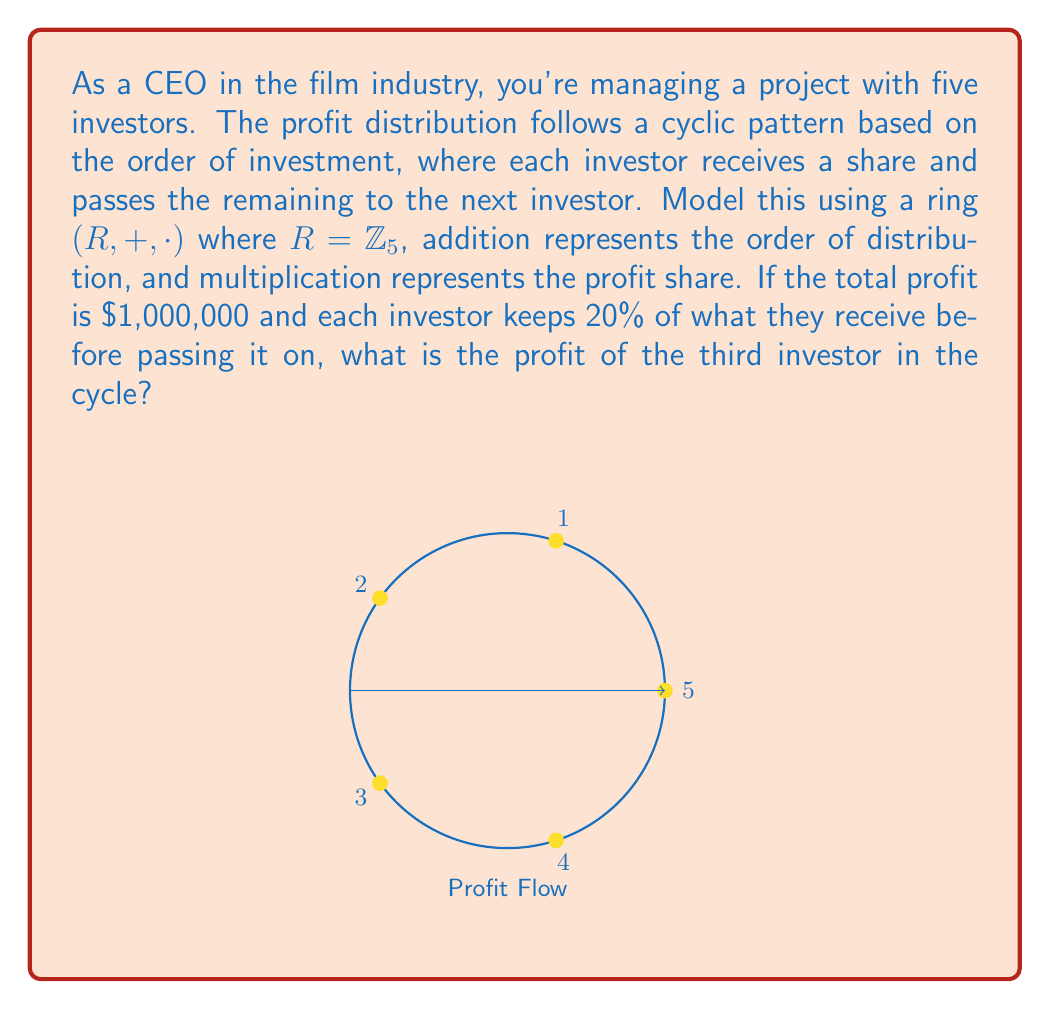Provide a solution to this math problem. Let's approach this step-by-step using ring theory:

1) In our ring $(R, +, \cdot)$, $R = \mathbb{Z}_5$ represents the five investors.

2) The addition operation $+$ in $\mathbb{Z}_5$ models the cyclic order of distribution. For example, $3 + 1 = 4$ means after the third investor, it goes to the fourth.

3) The multiplication operation $\cdot$ represents the profit share. In this case, each investor keeps 20% (or 0.2) and passes on 80% (or 0.8).

4) The profit distribution can be modeled as:
   $$P_i = 0.2 \cdot (0.8)^{i-1} \cdot 1,000,000$$
   where $P_i$ is the profit of the $i$-th investor in the cycle.

5) For the third investor $(i = 3)$:
   $$P_3 = 0.2 \cdot (0.8)^2 \cdot 1,000,000$$

6) Let's calculate:
   $$(0.8)^2 = 0.64$$
   $$0.2 \cdot 0.64 \cdot 1,000,000 = 128,000$$

Therefore, the third investor in the cycle will receive $\$128,000$.
Answer: $\$128,000$ 